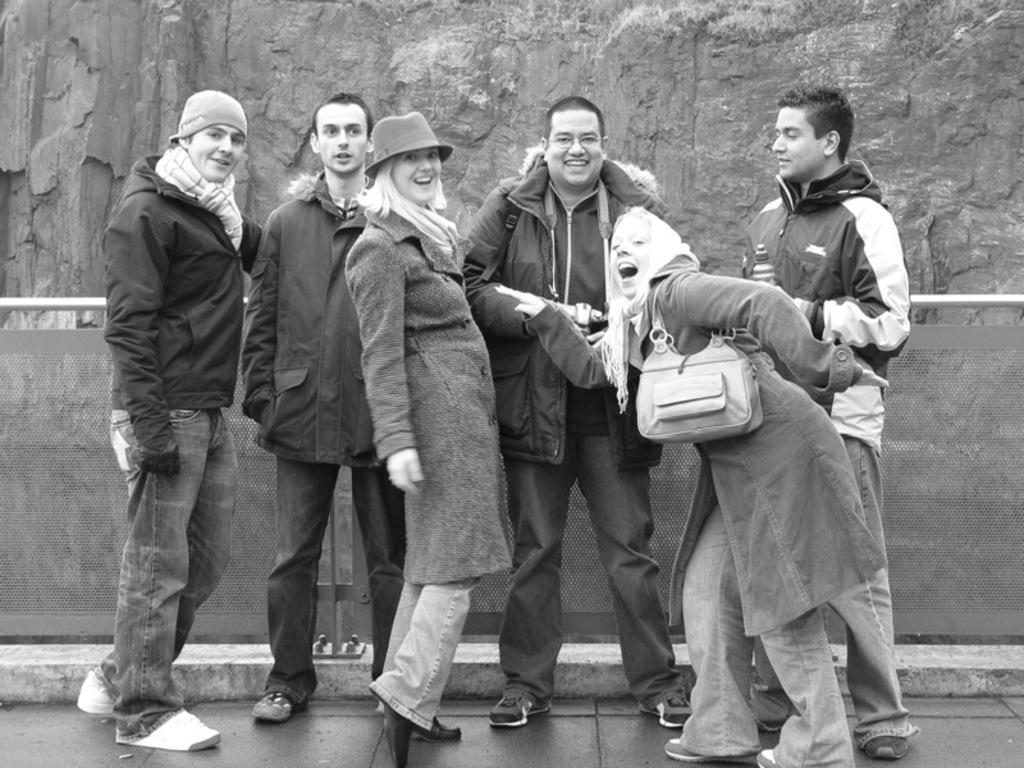Could you give a brief overview of what you see in this image? In the picture we can see a group of people standing on the path and they are smiling and in the background, we can see a wall and behind it we can see a rock wall. 